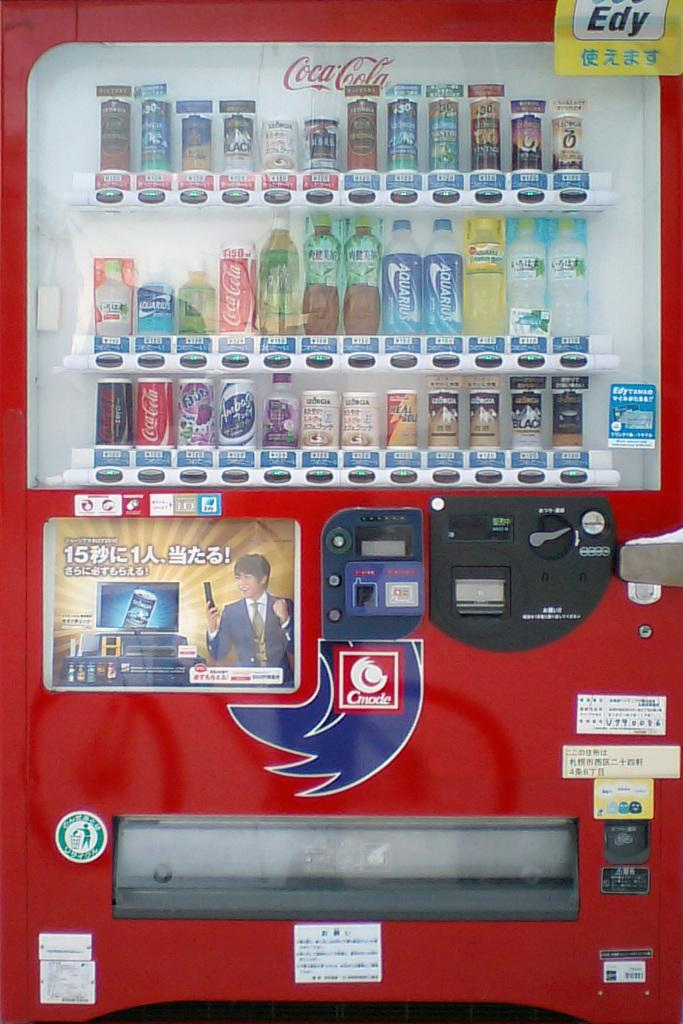<image>
Provide a brief description of the given image. A Coca Cola vending machine that says Edy in the top corner. 